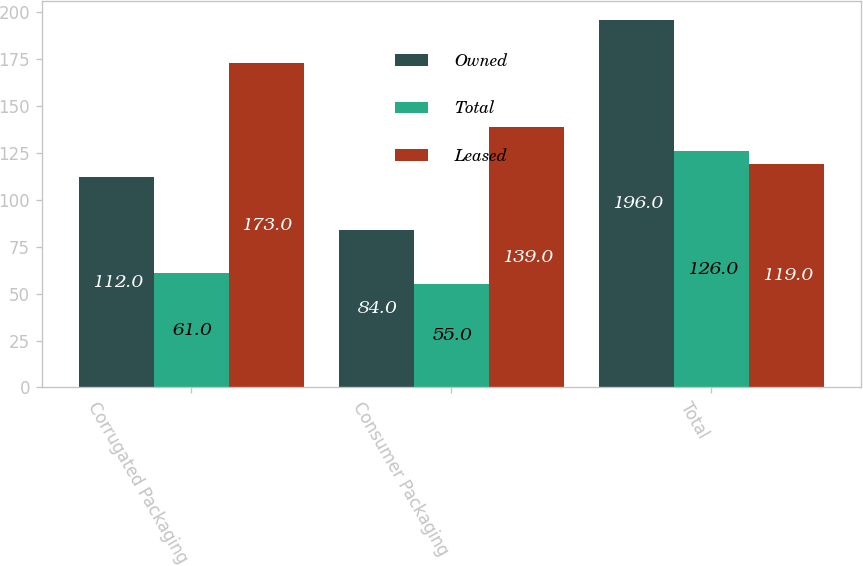<chart> <loc_0><loc_0><loc_500><loc_500><stacked_bar_chart><ecel><fcel>Corrugated Packaging<fcel>Consumer Packaging<fcel>Total<nl><fcel>Owned<fcel>112<fcel>84<fcel>196<nl><fcel>Total<fcel>61<fcel>55<fcel>126<nl><fcel>Leased<fcel>173<fcel>139<fcel>119<nl></chart> 